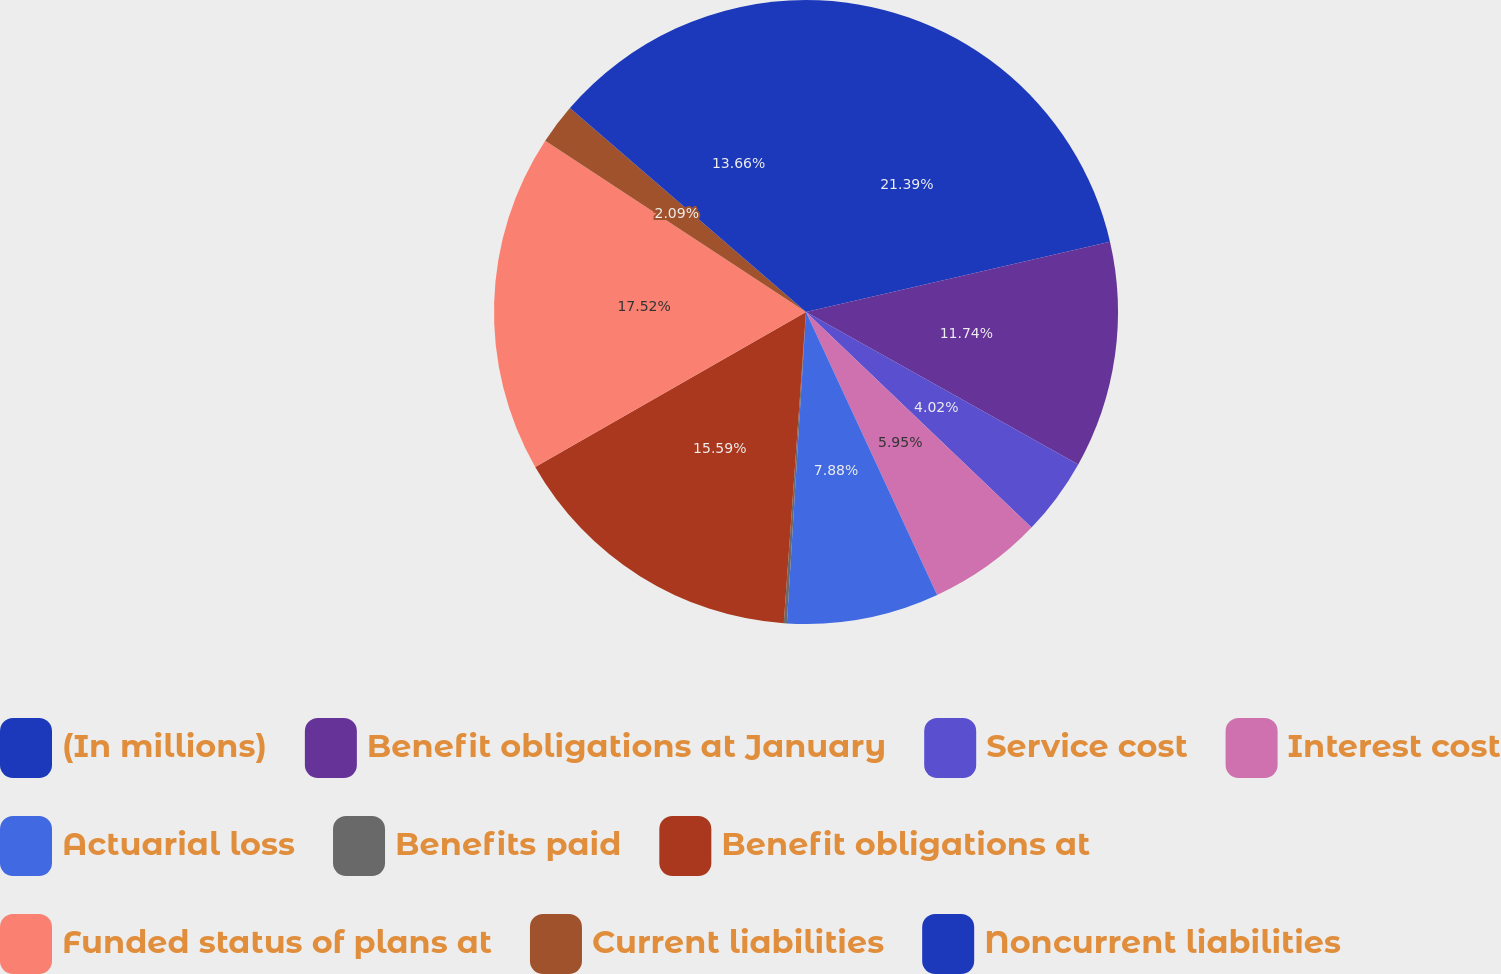Convert chart to OTSL. <chart><loc_0><loc_0><loc_500><loc_500><pie_chart><fcel>(In millions)<fcel>Benefit obligations at January<fcel>Service cost<fcel>Interest cost<fcel>Actuarial loss<fcel>Benefits paid<fcel>Benefit obligations at<fcel>Funded status of plans at<fcel>Current liabilities<fcel>Noncurrent liabilities<nl><fcel>21.38%<fcel>11.74%<fcel>4.02%<fcel>5.95%<fcel>7.88%<fcel>0.16%<fcel>15.59%<fcel>17.52%<fcel>2.09%<fcel>13.66%<nl></chart> 